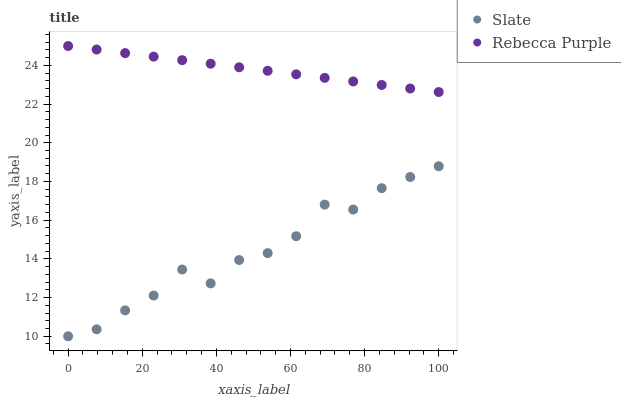Does Slate have the minimum area under the curve?
Answer yes or no. Yes. Does Rebecca Purple have the maximum area under the curve?
Answer yes or no. Yes. Does Rebecca Purple have the minimum area under the curve?
Answer yes or no. No. Is Rebecca Purple the smoothest?
Answer yes or no. Yes. Is Slate the roughest?
Answer yes or no. Yes. Is Rebecca Purple the roughest?
Answer yes or no. No. Does Slate have the lowest value?
Answer yes or no. Yes. Does Rebecca Purple have the lowest value?
Answer yes or no. No. Does Rebecca Purple have the highest value?
Answer yes or no. Yes. Is Slate less than Rebecca Purple?
Answer yes or no. Yes. Is Rebecca Purple greater than Slate?
Answer yes or no. Yes. Does Slate intersect Rebecca Purple?
Answer yes or no. No. 